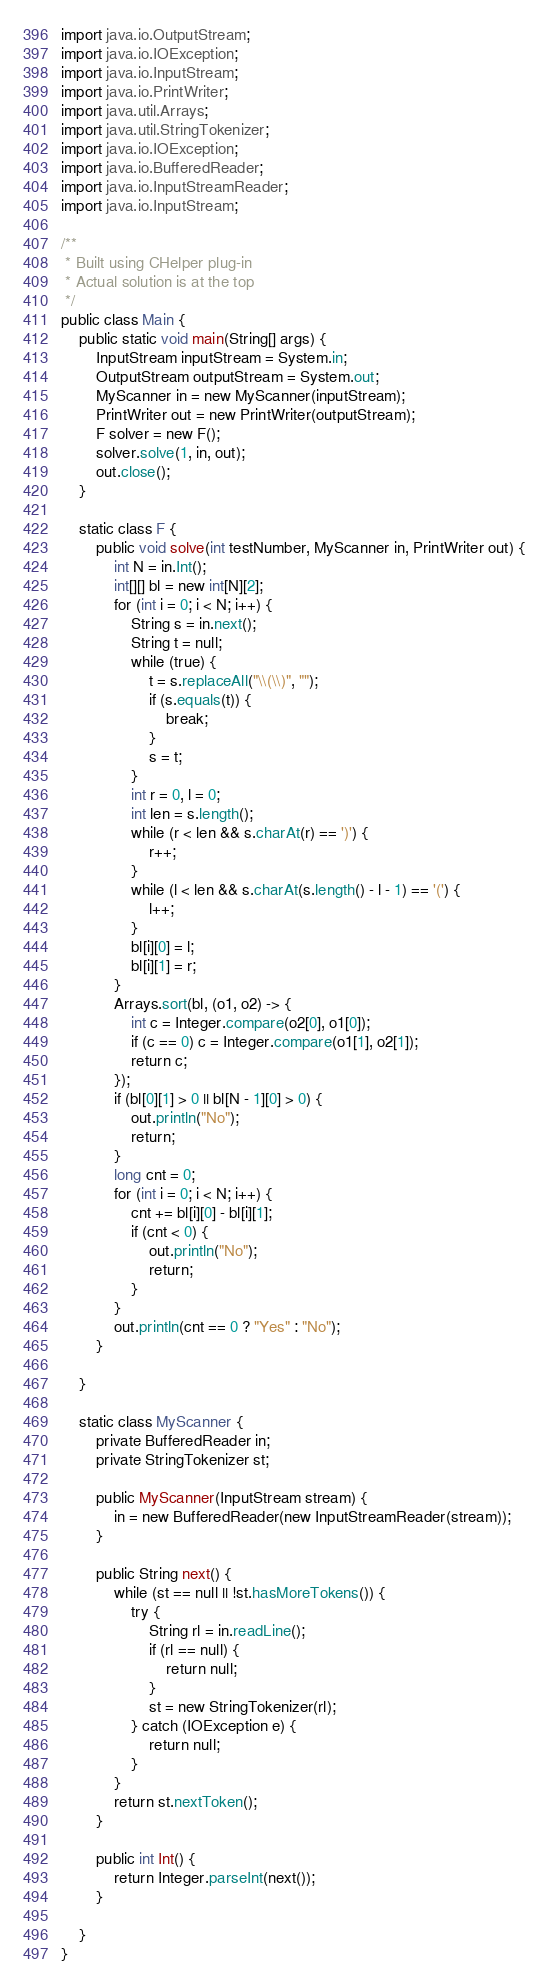Convert code to text. <code><loc_0><loc_0><loc_500><loc_500><_Java_>import java.io.OutputStream;
import java.io.IOException;
import java.io.InputStream;
import java.io.PrintWriter;
import java.util.Arrays;
import java.util.StringTokenizer;
import java.io.IOException;
import java.io.BufferedReader;
import java.io.InputStreamReader;
import java.io.InputStream;

/**
 * Built using CHelper plug-in
 * Actual solution is at the top
 */
public class Main {
    public static void main(String[] args) {
        InputStream inputStream = System.in;
        OutputStream outputStream = System.out;
        MyScanner in = new MyScanner(inputStream);
        PrintWriter out = new PrintWriter(outputStream);
        F solver = new F();
        solver.solve(1, in, out);
        out.close();
    }

    static class F {
        public void solve(int testNumber, MyScanner in, PrintWriter out) {
            int N = in.Int();
            int[][] bl = new int[N][2];
            for (int i = 0; i < N; i++) {
                String s = in.next();
                String t = null;
                while (true) {
                    t = s.replaceAll("\\(\\)", "");
                    if (s.equals(t)) {
                        break;
                    }
                    s = t;
                }
                int r = 0, l = 0;
                int len = s.length();
                while (r < len && s.charAt(r) == ')') {
                    r++;
                }
                while (l < len && s.charAt(s.length() - l - 1) == '(') {
                    l++;
                }
                bl[i][0] = l;
                bl[i][1] = r;
            }
            Arrays.sort(bl, (o1, o2) -> {
                int c = Integer.compare(o2[0], o1[0]);
                if (c == 0) c = Integer.compare(o1[1], o2[1]);
                return c;
            });
            if (bl[0][1] > 0 || bl[N - 1][0] > 0) {
                out.println("No");
                return;
            }
            long cnt = 0;
            for (int i = 0; i < N; i++) {
                cnt += bl[i][0] - bl[i][1];
                if (cnt < 0) {
                    out.println("No");
                    return;
                }
            }
            out.println(cnt == 0 ? "Yes" : "No");
        }

    }

    static class MyScanner {
        private BufferedReader in;
        private StringTokenizer st;

        public MyScanner(InputStream stream) {
            in = new BufferedReader(new InputStreamReader(stream));
        }

        public String next() {
            while (st == null || !st.hasMoreTokens()) {
                try {
                    String rl = in.readLine();
                    if (rl == null) {
                        return null;
                    }
                    st = new StringTokenizer(rl);
                } catch (IOException e) {
                    return null;
                }
            }
            return st.nextToken();
        }

        public int Int() {
            return Integer.parseInt(next());
        }

    }
}

</code> 